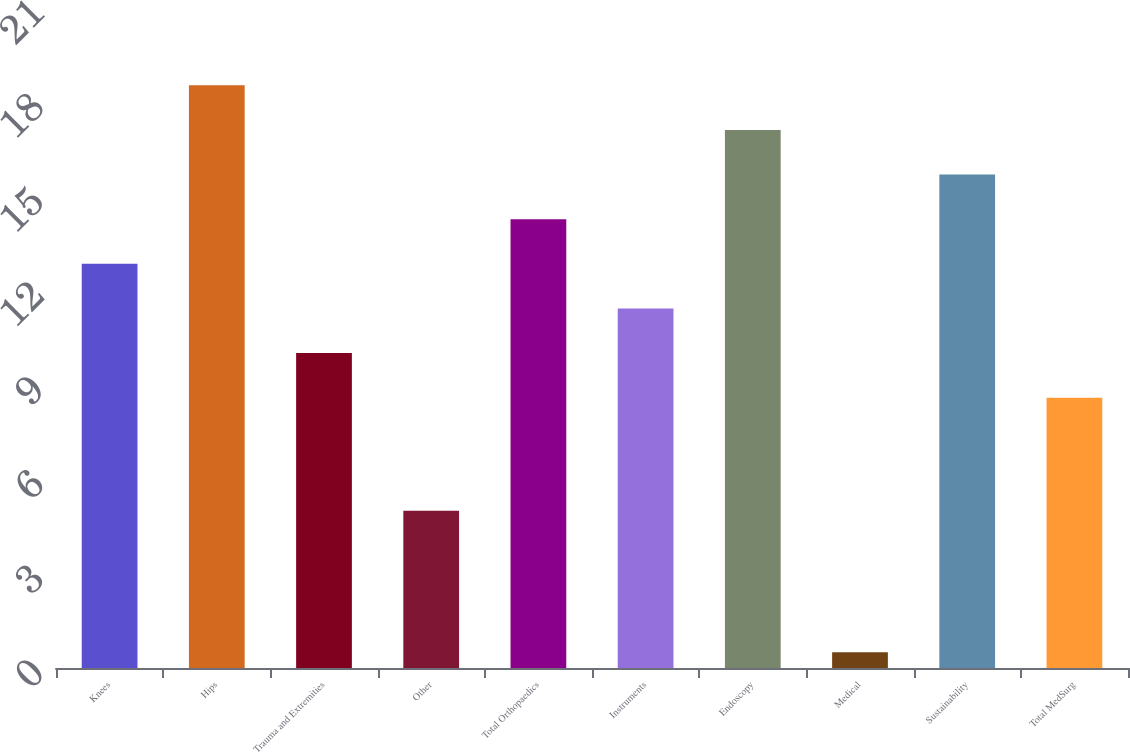<chart> <loc_0><loc_0><loc_500><loc_500><bar_chart><fcel>Knees<fcel>Hips<fcel>Trauma and Extremities<fcel>Other<fcel>Total Orthopaedics<fcel>Instruments<fcel>Endoscopy<fcel>Medical<fcel>Sustainability<fcel>Total MedSurg<nl><fcel>12.86<fcel>18.54<fcel>10.02<fcel>5<fcel>14.28<fcel>11.44<fcel>17.12<fcel>0.5<fcel>15.7<fcel>8.6<nl></chart> 